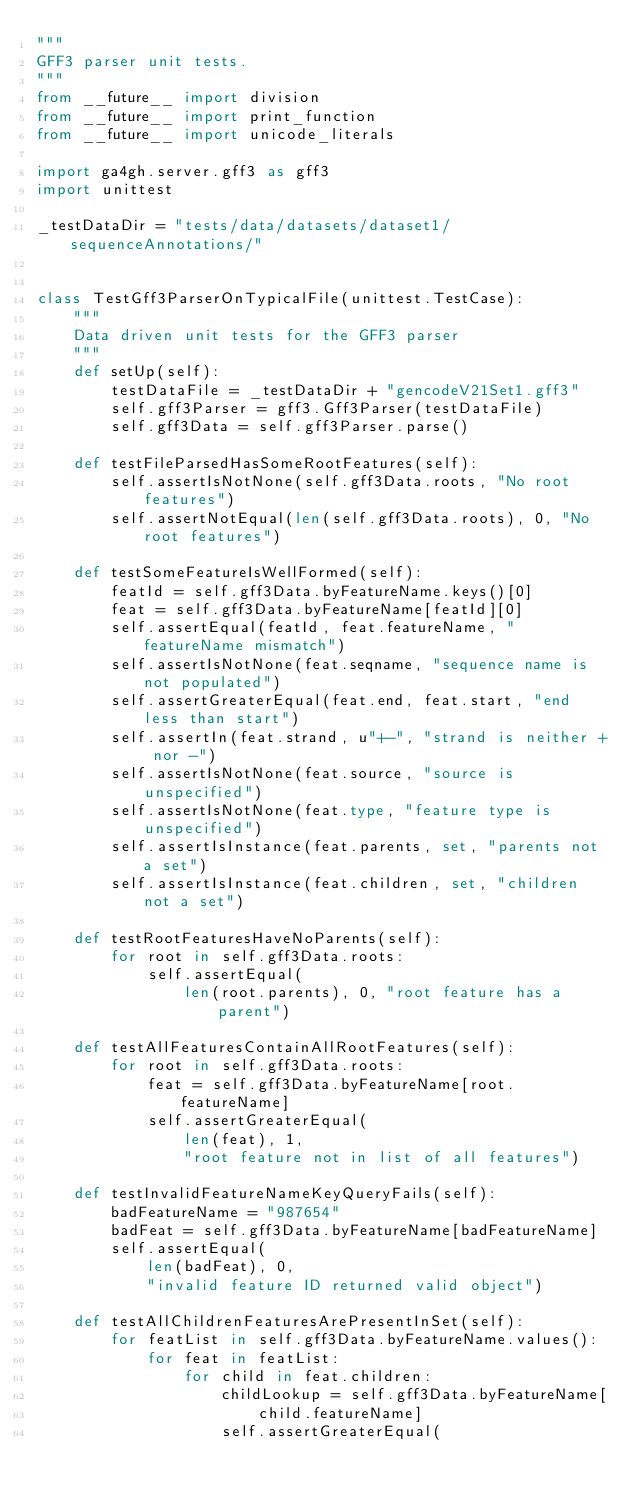<code> <loc_0><loc_0><loc_500><loc_500><_Python_>"""
GFF3 parser unit tests.
"""
from __future__ import division
from __future__ import print_function
from __future__ import unicode_literals

import ga4gh.server.gff3 as gff3
import unittest

_testDataDir = "tests/data/datasets/dataset1/sequenceAnnotations/"


class TestGff3ParserOnTypicalFile(unittest.TestCase):
    """
    Data driven unit tests for the GFF3 parser
    """
    def setUp(self):
        testDataFile = _testDataDir + "gencodeV21Set1.gff3"
        self.gff3Parser = gff3.Gff3Parser(testDataFile)
        self.gff3Data = self.gff3Parser.parse()

    def testFileParsedHasSomeRootFeatures(self):
        self.assertIsNotNone(self.gff3Data.roots, "No root features")
        self.assertNotEqual(len(self.gff3Data.roots), 0, "No root features")

    def testSomeFeatureIsWellFormed(self):
        featId = self.gff3Data.byFeatureName.keys()[0]
        feat = self.gff3Data.byFeatureName[featId][0]
        self.assertEqual(featId, feat.featureName, "featureName mismatch")
        self.assertIsNotNone(feat.seqname, "sequence name is not populated")
        self.assertGreaterEqual(feat.end, feat.start, "end less than start")
        self.assertIn(feat.strand, u"+-", "strand is neither + nor -")
        self.assertIsNotNone(feat.source, "source is unspecified")
        self.assertIsNotNone(feat.type, "feature type is unspecified")
        self.assertIsInstance(feat.parents, set, "parents not a set")
        self.assertIsInstance(feat.children, set, "children not a set")

    def testRootFeaturesHaveNoParents(self):
        for root in self.gff3Data.roots:
            self.assertEqual(
                len(root.parents), 0, "root feature has a parent")

    def testAllFeaturesContainAllRootFeatures(self):
        for root in self.gff3Data.roots:
            feat = self.gff3Data.byFeatureName[root.featureName]
            self.assertGreaterEqual(
                len(feat), 1,
                "root feature not in list of all features")

    def testInvalidFeatureNameKeyQueryFails(self):
        badFeatureName = "987654"
        badFeat = self.gff3Data.byFeatureName[badFeatureName]
        self.assertEqual(
            len(badFeat), 0,
            "invalid feature ID returned valid object")

    def testAllChildrenFeaturesArePresentInSet(self):
        for featList in self.gff3Data.byFeatureName.values():
            for feat in featList:
                for child in feat.children:
                    childLookup = self.gff3Data.byFeatureName[
                        child.featureName]
                    self.assertGreaterEqual(</code> 